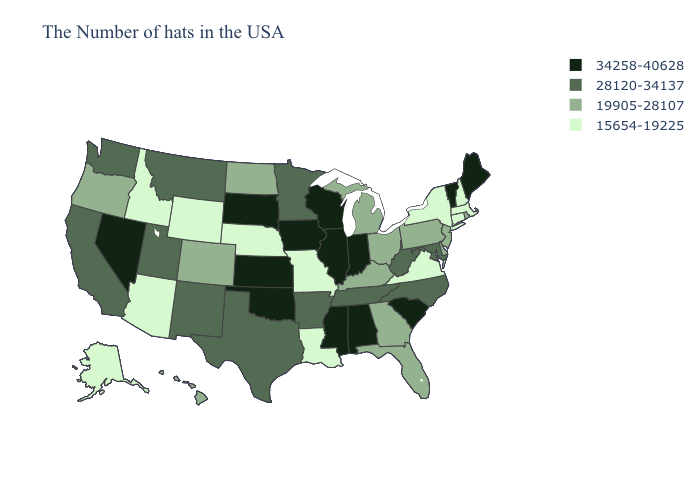Among the states that border Wisconsin , which have the lowest value?
Write a very short answer. Michigan. Among the states that border Kentucky , which have the highest value?
Keep it brief. Indiana, Illinois. Does Colorado have the highest value in the USA?
Concise answer only. No. Among the states that border South Dakota , does Iowa have the highest value?
Answer briefly. Yes. What is the value of Arkansas?
Give a very brief answer. 28120-34137. Among the states that border Wyoming , which have the lowest value?
Be succinct. Nebraska, Idaho. Name the states that have a value in the range 28120-34137?
Concise answer only. Maryland, North Carolina, West Virginia, Tennessee, Arkansas, Minnesota, Texas, New Mexico, Utah, Montana, California, Washington. Among the states that border Texas , does Oklahoma have the lowest value?
Give a very brief answer. No. Does Maine have a higher value than Oklahoma?
Answer briefly. No. Which states have the lowest value in the West?
Give a very brief answer. Wyoming, Arizona, Idaho, Alaska. Does Wisconsin have a lower value than New Hampshire?
Concise answer only. No. Name the states that have a value in the range 19905-28107?
Answer briefly. Rhode Island, New Jersey, Delaware, Pennsylvania, Ohio, Florida, Georgia, Michigan, Kentucky, North Dakota, Colorado, Oregon, Hawaii. Which states hav the highest value in the Northeast?
Give a very brief answer. Maine, Vermont. What is the value of Washington?
Short answer required. 28120-34137. What is the lowest value in the West?
Be succinct. 15654-19225. 